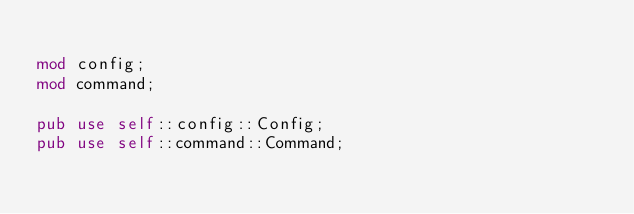Convert code to text. <code><loc_0><loc_0><loc_500><loc_500><_Rust_>
mod config;
mod command;

pub use self::config::Config;
pub use self::command::Command;
</code> 